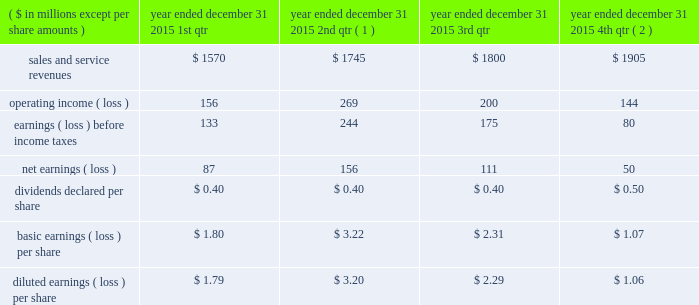Of exercise for stock options exercised or at period end for outstanding stock options , less the applicable exercise price .
The company issued new shares to satisfy exercised stock options .
Compensation expense the company recorded $ 43 million , $ 34 million , and $ 44 million of expense related to stock awards for the years ended december 31 , 2015 , 2014 , and 2013 , respectively .
The company recorded $ 17 million , $ 13 million , and $ 17 million as a tax benefit related to stock awards and stock options for the years ended december 31 , 2015 , 2014 , and 2013 , respectively .
The company recognized tax benefits for the years ended december 31 , 2015 , 2014 , and 2013 , of $ 41 million , $ 53 million , and $ 32 million , respectively , from the issuance of stock in settlement of stock awards , and $ 4 million , $ 5 million , and $ 4 million for the years ended december 31 , 2015 , 2014 , and 2013 , respectively , from the exercise of stock options .
Unrecognized compensation expense as of december 31 , 2015 , the company had less than $ 1 million of unrecognized compensation expense associated with rsrs granted in 2015 and 2014 , which will be recognized over a weighted average period of 1.0 year , and $ 25 million of unrecognized expense associated with rpsrs granted in 2015 , 2014 , and 2013 , which will be recognized over a weighted average period of 0.6 years .
As of december 31 , 2015 , the company had no unrecognized compensation expense related to stock options .
Compensation expense for stock options was fully recognized as of december 31 , 2013 .
20 .
Unaudited selected quarterly data unaudited quarterly financial results for the years ended december 31 , 2015 and 2014 , are set forth in the tables: .
( 1 ) in the second quarter of 2015 , the company recorded a $ 59 million goodwill impairment charge .
During the same period , the company recorded $ 136 million of operating income as a result of the aon settlement .
( 2 ) in the fourth quarter of 2015 , the company recorded $ 16 million goodwill impairment and $ 27 million intangible asset impairment charges. .
Between 2015 and 2013 what was the average compensation expense related to the issuing of the stock award in millions? 
Rationale: the average is the sum of all amounts divide by the number of amounts
Computations: (((43 + 34) + 44) / 3)
Answer: 40.33333. 